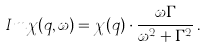<formula> <loc_0><loc_0><loc_500><loc_500>I m \chi ( q , \omega ) = \chi ( q ) \cdot \frac { \omega \Gamma } { \omega ^ { 2 } + \Gamma ^ { 2 } } \, .</formula> 